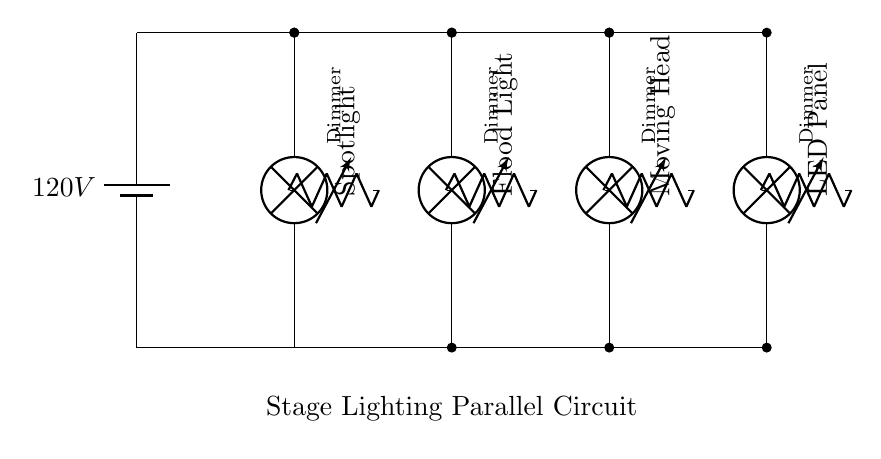What is the main voltage of this circuit? The circuit is powered by a battery labeled as 120V. This value indicates the potential difference across the circuit.
Answer: 120V How many lamps are included in the circuit? The circuit diagram shows four distinct lamp components: a spotlight, a flood light, a moving head, and an LED panel. Counting these gives the total number of lamps.
Answer: 4 What type of components are used for dimming? The circuit includes variable resistors labeled as dimmers, which are used to control the brightness of each lamp. Each lamp has its own dimmer connected in series.
Answer: Dimmer Are the lamps in series or parallel? The lamps are arranged in parallel as indicated by the multiple paths leading from the voltage source to each lamp; this allows each lamp to operate independently of the others.
Answer: Parallel How does adding more lamps affect the current? Adding more lamps in parallel decreases the overall resistance of the circuit, allowing more current to flow through the source, as each lamp provides an additional pathway for current flow.
Answer: Increases What is the effect of the dimmers on the lamps? The dimmers allow for individual control of the brightness of each lamp, meaning that users can adjust the intensity of the light output from each lamp independently.
Answer: Individual brightness control 